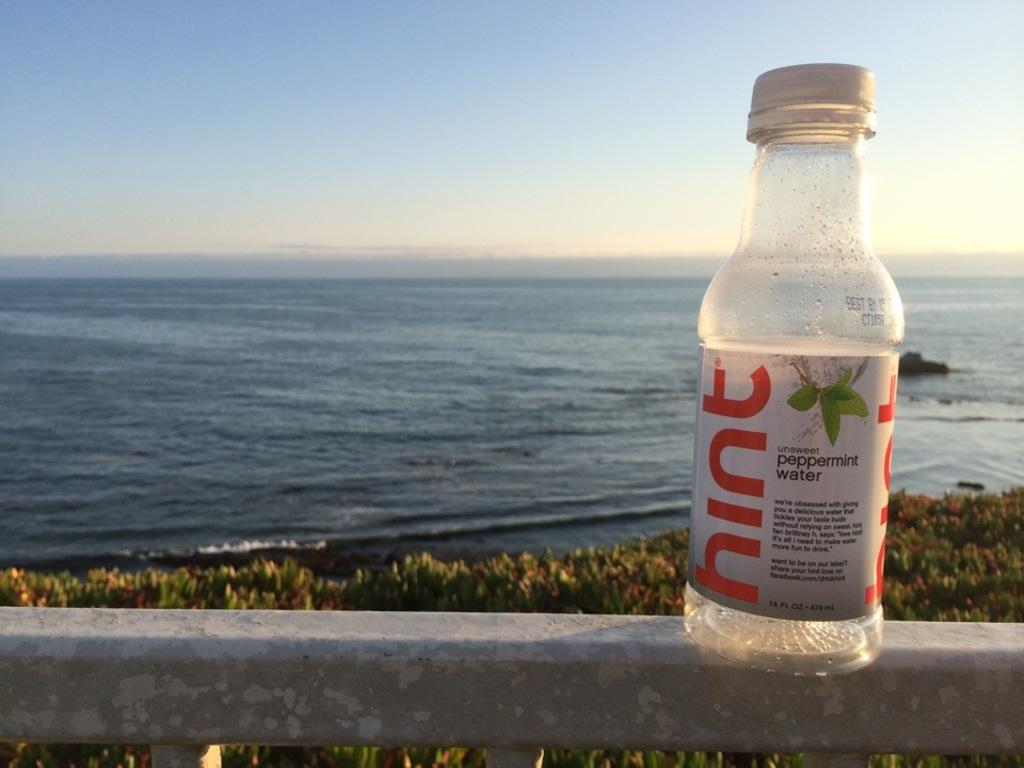Provide a one-sentence caption for the provided image. A BOTTLE OF HINT IS SITTING ON A RAIL WITH THE OCEAN IN FRONT OF IT. 